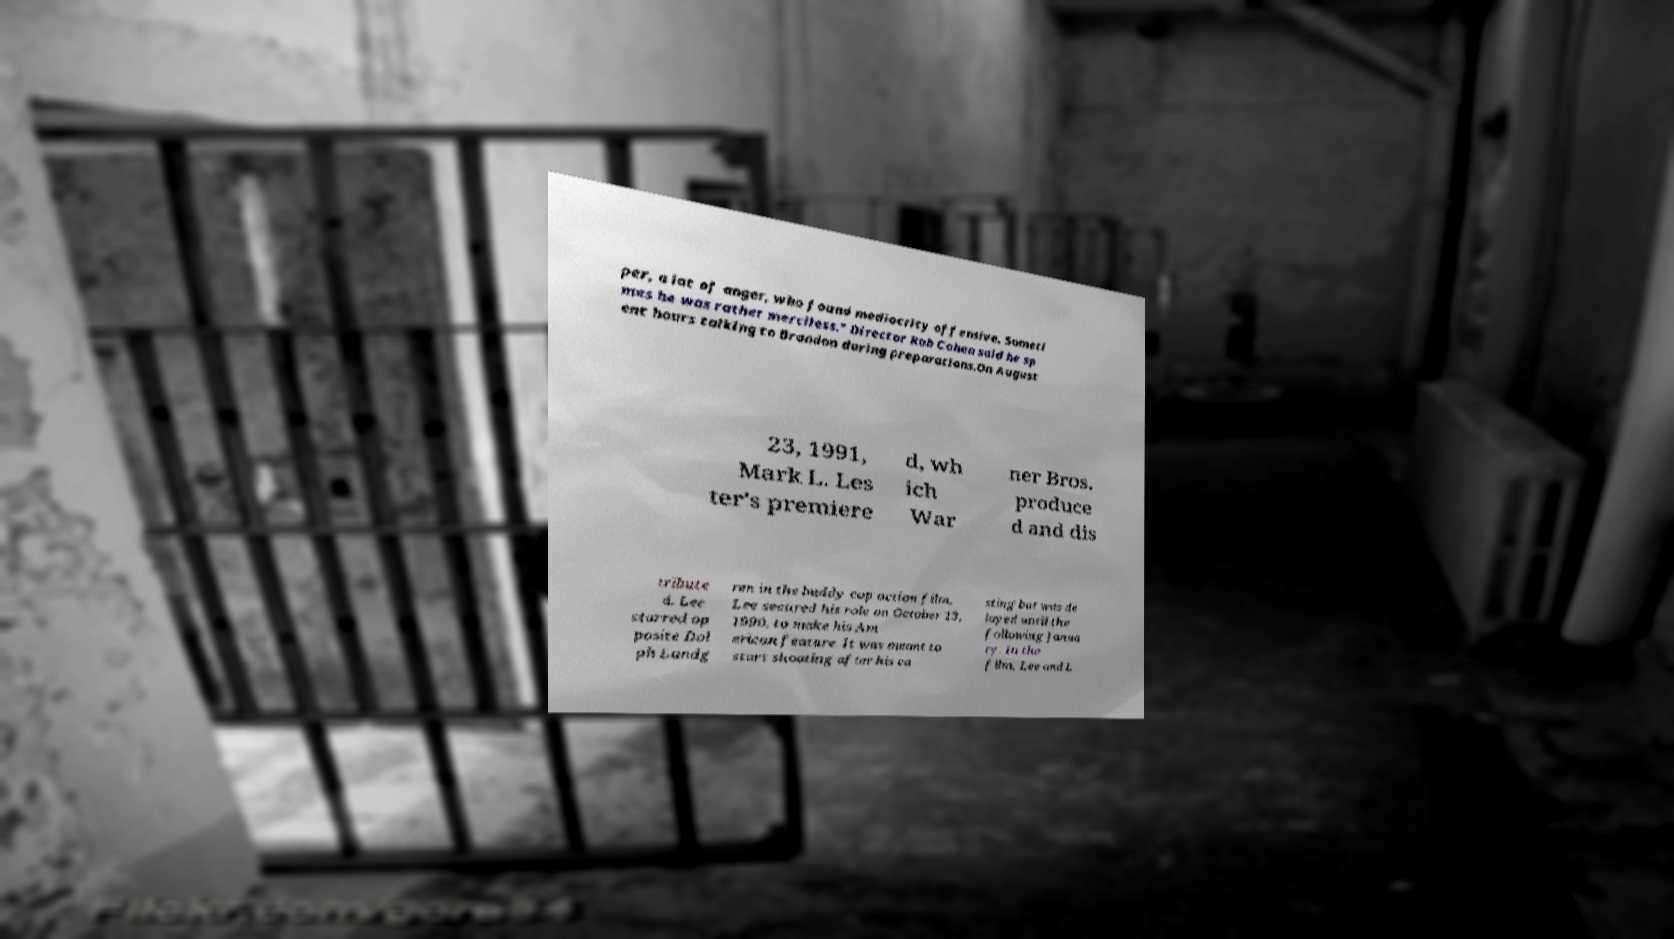Could you extract and type out the text from this image? per, a lot of anger, who found mediocrity offensive. Someti mes he was rather merciless." Director Rob Cohen said he sp ent hours talking to Brandon during preparations.On August 23, 1991, Mark L. Les ter's premiere d, wh ich War ner Bros. produce d and dis tribute d. Lee starred op posite Dol ph Lundg ren in the buddy cop action film. Lee secured his role on October 13, 1990, to make his Am erican feature. It was meant to start shooting after his ca sting but was de layed until the following Janua ry. In the film, Lee and L 